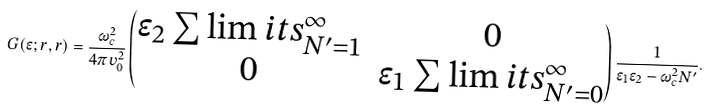<formula> <loc_0><loc_0><loc_500><loc_500>G ( \epsilon ; r , r ) = \frac { \omega _ { c } ^ { 2 } } { 4 \pi v _ { 0 } ^ { 2 } } \begin{pmatrix} \epsilon _ { 2 } \sum \lim i t s _ { N ^ { \prime } = 1 } ^ { \infty } & 0 \\ 0 & \epsilon _ { 1 } \sum \lim i t s _ { N ^ { \prime } = 0 } ^ { \infty } \end{pmatrix} \frac { 1 } { \epsilon _ { 1 } \epsilon _ { 2 } - \omega _ { c } ^ { 2 } N ^ { \prime } } .</formula> 